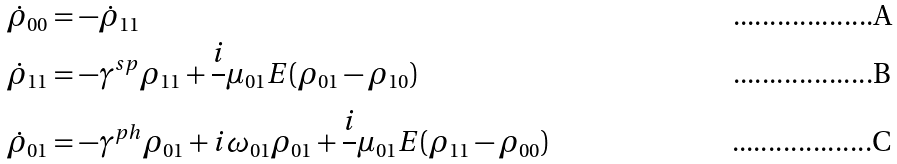<formula> <loc_0><loc_0><loc_500><loc_500>\dot { \rho } _ { 0 0 } & = - \dot { \rho } _ { 1 1 } \\ \dot { \rho } _ { 1 1 } & = - { \gamma } ^ { s p } \rho _ { 1 1 } + \frac { i } { } \mu _ { 0 1 } E ( \rho _ { 0 1 } - \rho _ { 1 0 } ) \\ \dot { \rho } _ { 0 1 } & = - { \gamma } ^ { p h } \rho _ { 0 1 } + i \omega _ { 0 1 } \rho _ { 0 1 } + \frac { i } { } \mu _ { 0 1 } E ( \rho _ { 1 1 } - \rho _ { 0 0 } )</formula> 